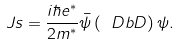Convert formula to latex. <formula><loc_0><loc_0><loc_500><loc_500>\ J s = \frac { i \hbar { e } ^ { * } } { 2 m ^ { * } } \bar { \psi } \left ( \ D b D \right ) \psi .</formula> 